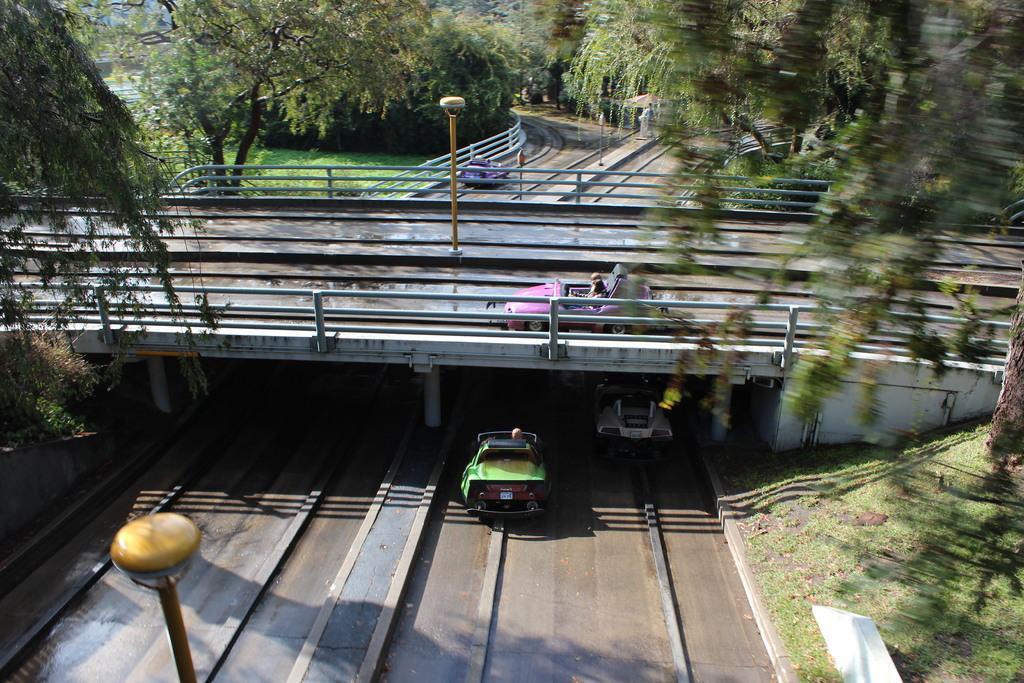Please provide a concise description of this image. In this image we can see vehicles on the roads. There is a bridge with pillars. Also we can see many trees. On the ground there is grass. Also there are light poles. 